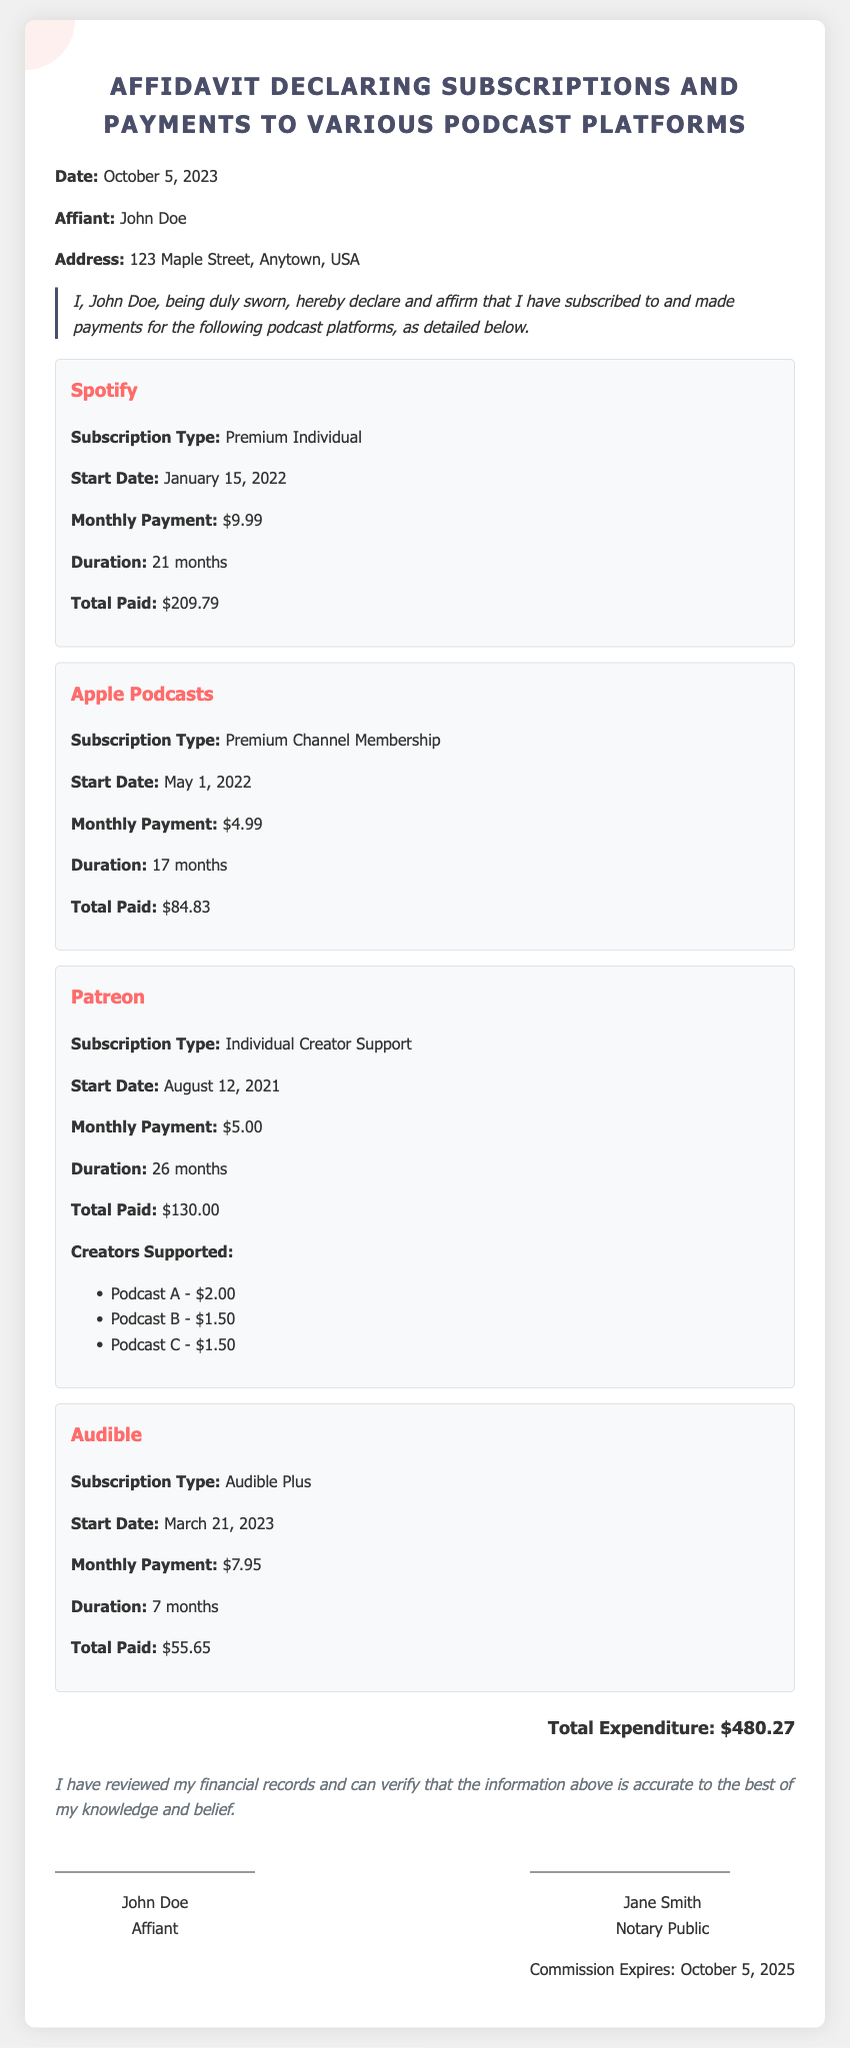What is the date of the affidavit? The affidavit was executed on October 5, 2023, as stated at the beginning of the document.
Answer: October 5, 2023 Who is the affiant? The document identifies John Doe as the affiant who is declaring the subscriptions and payments.
Answer: John Doe What is the total expenditure? The total amount paid for all subscriptions is calculated and stated at the end of the document.
Answer: $480.27 How many months did the Patreon subscription last? The document specifies that the Patreon subscription duration is listed as 26 months.
Answer: 26 months What type of subscription is listed for Spotify? The affidavit outlines that the subscription type for Spotify is detailed in its respective section.
Answer: Premium Individual Which platform has the highest total paid? A comparison of the total paid for each subscription will indicate which one is the highest.
Answer: Spotify When does the notary commission expire? The document includes the expiration date of the notary's commission, which is explicitly stated.
Answer: October 5, 2025 How many creators are supported in the Patreon subscription? The text lists the creators supported under the Patreon subscription in the document.
Answer: Three creators What is the monthly payment for Audible? The monthly payment amount for the Audible subscription is explicitly listed in the document.
Answer: $7.95 